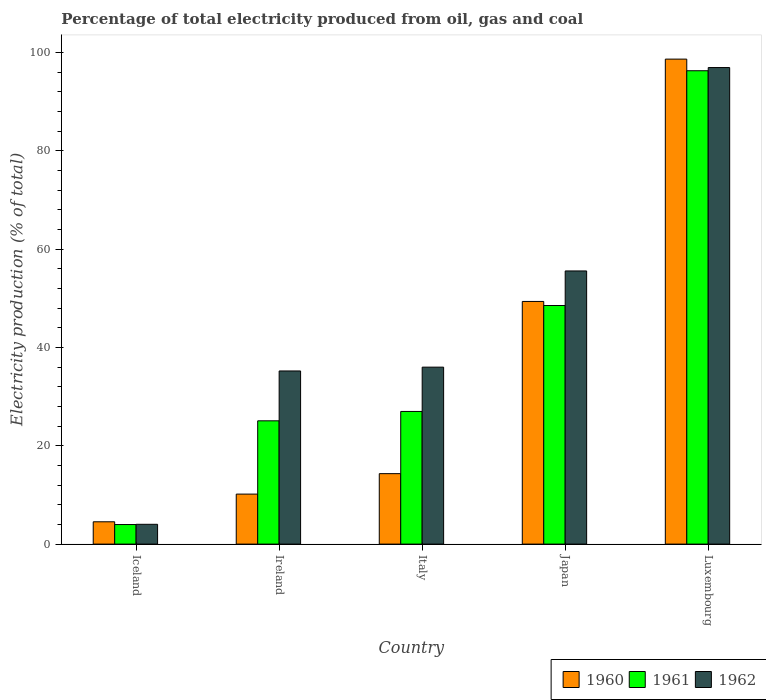How many bars are there on the 3rd tick from the left?
Your answer should be very brief. 3. What is the label of the 3rd group of bars from the left?
Offer a very short reply. Italy. What is the electricity production in in 1961 in Italy?
Give a very brief answer. 26.98. Across all countries, what is the maximum electricity production in in 1960?
Provide a succinct answer. 98.63. Across all countries, what is the minimum electricity production in in 1961?
Ensure brevity in your answer.  3.98. In which country was the electricity production in in 1962 maximum?
Give a very brief answer. Luxembourg. What is the total electricity production in in 1961 in the graph?
Keep it short and to the point. 200.82. What is the difference between the electricity production in in 1960 in Ireland and that in Japan?
Ensure brevity in your answer.  -39.18. What is the difference between the electricity production in in 1960 in Luxembourg and the electricity production in in 1961 in Iceland?
Give a very brief answer. 94.65. What is the average electricity production in in 1962 per country?
Your answer should be very brief. 45.54. What is the difference between the electricity production in of/in 1962 and electricity production in of/in 1961 in Japan?
Make the answer very short. 7.03. In how many countries, is the electricity production in in 1962 greater than 40 %?
Your answer should be compact. 2. What is the ratio of the electricity production in in 1962 in Ireland to that in Japan?
Your response must be concise. 0.63. What is the difference between the highest and the second highest electricity production in in 1960?
Provide a succinct answer. -49.28. What is the difference between the highest and the lowest electricity production in in 1962?
Give a very brief answer. 92.89. In how many countries, is the electricity production in in 1962 greater than the average electricity production in in 1962 taken over all countries?
Ensure brevity in your answer.  2. Is the sum of the electricity production in in 1961 in Japan and Luxembourg greater than the maximum electricity production in in 1960 across all countries?
Offer a very short reply. Yes. What does the 3rd bar from the right in Iceland represents?
Provide a short and direct response. 1960. Is it the case that in every country, the sum of the electricity production in in 1962 and electricity production in in 1960 is greater than the electricity production in in 1961?
Ensure brevity in your answer.  Yes. Are all the bars in the graph horizontal?
Provide a short and direct response. No. Are the values on the major ticks of Y-axis written in scientific E-notation?
Offer a very short reply. No. How are the legend labels stacked?
Ensure brevity in your answer.  Horizontal. What is the title of the graph?
Give a very brief answer. Percentage of total electricity produced from oil, gas and coal. What is the label or title of the X-axis?
Make the answer very short. Country. What is the label or title of the Y-axis?
Keep it short and to the point. Electricity production (% of total). What is the Electricity production (% of total) of 1960 in Iceland?
Make the answer very short. 4.54. What is the Electricity production (% of total) of 1961 in Iceland?
Give a very brief answer. 3.98. What is the Electricity production (% of total) of 1962 in Iceland?
Your response must be concise. 4.03. What is the Electricity production (% of total) of 1960 in Ireland?
Your answer should be very brief. 10.17. What is the Electricity production (% of total) of 1961 in Ireland?
Your answer should be very brief. 25.07. What is the Electricity production (% of total) of 1962 in Ireland?
Keep it short and to the point. 35.21. What is the Electricity production (% of total) in 1960 in Italy?
Provide a succinct answer. 14.33. What is the Electricity production (% of total) of 1961 in Italy?
Provide a short and direct response. 26.98. What is the Electricity production (% of total) in 1962 in Italy?
Provide a succinct answer. 35.99. What is the Electricity production (% of total) of 1960 in Japan?
Offer a terse response. 49.35. What is the Electricity production (% of total) in 1961 in Japan?
Your response must be concise. 48.52. What is the Electricity production (% of total) of 1962 in Japan?
Provide a succinct answer. 55.56. What is the Electricity production (% of total) in 1960 in Luxembourg?
Your answer should be very brief. 98.63. What is the Electricity production (% of total) of 1961 in Luxembourg?
Offer a very short reply. 96.27. What is the Electricity production (% of total) of 1962 in Luxembourg?
Offer a very short reply. 96.92. Across all countries, what is the maximum Electricity production (% of total) in 1960?
Your response must be concise. 98.63. Across all countries, what is the maximum Electricity production (% of total) in 1961?
Your response must be concise. 96.27. Across all countries, what is the maximum Electricity production (% of total) of 1962?
Your answer should be compact. 96.92. Across all countries, what is the minimum Electricity production (% of total) in 1960?
Offer a terse response. 4.54. Across all countries, what is the minimum Electricity production (% of total) in 1961?
Make the answer very short. 3.98. Across all countries, what is the minimum Electricity production (% of total) of 1962?
Your response must be concise. 4.03. What is the total Electricity production (% of total) in 1960 in the graph?
Make the answer very short. 177.02. What is the total Electricity production (% of total) in 1961 in the graph?
Offer a very short reply. 200.82. What is the total Electricity production (% of total) in 1962 in the graph?
Offer a very short reply. 227.7. What is the difference between the Electricity production (% of total) of 1960 in Iceland and that in Ireland?
Provide a short and direct response. -5.63. What is the difference between the Electricity production (% of total) of 1961 in Iceland and that in Ireland?
Offer a terse response. -21.09. What is the difference between the Electricity production (% of total) in 1962 in Iceland and that in Ireland?
Your response must be concise. -31.19. What is the difference between the Electricity production (% of total) of 1960 in Iceland and that in Italy?
Your response must be concise. -9.79. What is the difference between the Electricity production (% of total) in 1961 in Iceland and that in Italy?
Give a very brief answer. -23. What is the difference between the Electricity production (% of total) of 1962 in Iceland and that in Italy?
Give a very brief answer. -31.96. What is the difference between the Electricity production (% of total) of 1960 in Iceland and that in Japan?
Offer a very short reply. -44.81. What is the difference between the Electricity production (% of total) of 1961 in Iceland and that in Japan?
Make the answer very short. -44.54. What is the difference between the Electricity production (% of total) of 1962 in Iceland and that in Japan?
Your answer should be compact. -51.53. What is the difference between the Electricity production (% of total) of 1960 in Iceland and that in Luxembourg?
Provide a short and direct response. -94.1. What is the difference between the Electricity production (% of total) in 1961 in Iceland and that in Luxembourg?
Ensure brevity in your answer.  -92.29. What is the difference between the Electricity production (% of total) of 1962 in Iceland and that in Luxembourg?
Your response must be concise. -92.89. What is the difference between the Electricity production (% of total) of 1960 in Ireland and that in Italy?
Your answer should be compact. -4.16. What is the difference between the Electricity production (% of total) of 1961 in Ireland and that in Italy?
Provide a short and direct response. -1.91. What is the difference between the Electricity production (% of total) of 1962 in Ireland and that in Italy?
Provide a succinct answer. -0.78. What is the difference between the Electricity production (% of total) in 1960 in Ireland and that in Japan?
Offer a terse response. -39.18. What is the difference between the Electricity production (% of total) of 1961 in Ireland and that in Japan?
Provide a succinct answer. -23.45. What is the difference between the Electricity production (% of total) of 1962 in Ireland and that in Japan?
Keep it short and to the point. -20.34. What is the difference between the Electricity production (% of total) of 1960 in Ireland and that in Luxembourg?
Make the answer very short. -88.47. What is the difference between the Electricity production (% of total) of 1961 in Ireland and that in Luxembourg?
Make the answer very short. -71.2. What is the difference between the Electricity production (% of total) of 1962 in Ireland and that in Luxembourg?
Your response must be concise. -61.71. What is the difference between the Electricity production (% of total) in 1960 in Italy and that in Japan?
Give a very brief answer. -35.02. What is the difference between the Electricity production (% of total) in 1961 in Italy and that in Japan?
Your response must be concise. -21.55. What is the difference between the Electricity production (% of total) of 1962 in Italy and that in Japan?
Provide a succinct answer. -19.57. What is the difference between the Electricity production (% of total) of 1960 in Italy and that in Luxembourg?
Your response must be concise. -84.31. What is the difference between the Electricity production (% of total) of 1961 in Italy and that in Luxembourg?
Keep it short and to the point. -69.29. What is the difference between the Electricity production (% of total) of 1962 in Italy and that in Luxembourg?
Make the answer very short. -60.93. What is the difference between the Electricity production (% of total) of 1960 in Japan and that in Luxembourg?
Provide a succinct answer. -49.28. What is the difference between the Electricity production (% of total) in 1961 in Japan and that in Luxembourg?
Your response must be concise. -47.75. What is the difference between the Electricity production (% of total) in 1962 in Japan and that in Luxembourg?
Keep it short and to the point. -41.36. What is the difference between the Electricity production (% of total) of 1960 in Iceland and the Electricity production (% of total) of 1961 in Ireland?
Give a very brief answer. -20.53. What is the difference between the Electricity production (% of total) in 1960 in Iceland and the Electricity production (% of total) in 1962 in Ireland?
Provide a succinct answer. -30.67. What is the difference between the Electricity production (% of total) in 1961 in Iceland and the Electricity production (% of total) in 1962 in Ireland?
Ensure brevity in your answer.  -31.23. What is the difference between the Electricity production (% of total) in 1960 in Iceland and the Electricity production (% of total) in 1961 in Italy?
Offer a terse response. -22.44. What is the difference between the Electricity production (% of total) in 1960 in Iceland and the Electricity production (% of total) in 1962 in Italy?
Offer a terse response. -31.45. What is the difference between the Electricity production (% of total) of 1961 in Iceland and the Electricity production (% of total) of 1962 in Italy?
Ensure brevity in your answer.  -32.01. What is the difference between the Electricity production (% of total) in 1960 in Iceland and the Electricity production (% of total) in 1961 in Japan?
Make the answer very short. -43.99. What is the difference between the Electricity production (% of total) in 1960 in Iceland and the Electricity production (% of total) in 1962 in Japan?
Keep it short and to the point. -51.02. What is the difference between the Electricity production (% of total) in 1961 in Iceland and the Electricity production (% of total) in 1962 in Japan?
Give a very brief answer. -51.58. What is the difference between the Electricity production (% of total) in 1960 in Iceland and the Electricity production (% of total) in 1961 in Luxembourg?
Make the answer very short. -91.73. What is the difference between the Electricity production (% of total) in 1960 in Iceland and the Electricity production (% of total) in 1962 in Luxembourg?
Offer a terse response. -92.38. What is the difference between the Electricity production (% of total) in 1961 in Iceland and the Electricity production (% of total) in 1962 in Luxembourg?
Offer a terse response. -92.94. What is the difference between the Electricity production (% of total) in 1960 in Ireland and the Electricity production (% of total) in 1961 in Italy?
Your response must be concise. -16.81. What is the difference between the Electricity production (% of total) of 1960 in Ireland and the Electricity production (% of total) of 1962 in Italy?
Provide a succinct answer. -25.82. What is the difference between the Electricity production (% of total) of 1961 in Ireland and the Electricity production (% of total) of 1962 in Italy?
Make the answer very short. -10.92. What is the difference between the Electricity production (% of total) of 1960 in Ireland and the Electricity production (% of total) of 1961 in Japan?
Make the answer very short. -38.36. What is the difference between the Electricity production (% of total) in 1960 in Ireland and the Electricity production (% of total) in 1962 in Japan?
Make the answer very short. -45.39. What is the difference between the Electricity production (% of total) in 1961 in Ireland and the Electricity production (% of total) in 1962 in Japan?
Give a very brief answer. -30.48. What is the difference between the Electricity production (% of total) of 1960 in Ireland and the Electricity production (% of total) of 1961 in Luxembourg?
Provide a short and direct response. -86.1. What is the difference between the Electricity production (% of total) in 1960 in Ireland and the Electricity production (% of total) in 1962 in Luxembourg?
Make the answer very short. -86.75. What is the difference between the Electricity production (% of total) in 1961 in Ireland and the Electricity production (% of total) in 1962 in Luxembourg?
Ensure brevity in your answer.  -71.85. What is the difference between the Electricity production (% of total) of 1960 in Italy and the Electricity production (% of total) of 1961 in Japan?
Give a very brief answer. -34.2. What is the difference between the Electricity production (% of total) of 1960 in Italy and the Electricity production (% of total) of 1962 in Japan?
Your response must be concise. -41.23. What is the difference between the Electricity production (% of total) in 1961 in Italy and the Electricity production (% of total) in 1962 in Japan?
Provide a succinct answer. -28.58. What is the difference between the Electricity production (% of total) in 1960 in Italy and the Electricity production (% of total) in 1961 in Luxembourg?
Your response must be concise. -81.94. What is the difference between the Electricity production (% of total) in 1960 in Italy and the Electricity production (% of total) in 1962 in Luxembourg?
Make the answer very short. -82.59. What is the difference between the Electricity production (% of total) in 1961 in Italy and the Electricity production (% of total) in 1962 in Luxembourg?
Offer a terse response. -69.94. What is the difference between the Electricity production (% of total) in 1960 in Japan and the Electricity production (% of total) in 1961 in Luxembourg?
Provide a succinct answer. -46.92. What is the difference between the Electricity production (% of total) in 1960 in Japan and the Electricity production (% of total) in 1962 in Luxembourg?
Your response must be concise. -47.57. What is the difference between the Electricity production (% of total) in 1961 in Japan and the Electricity production (% of total) in 1962 in Luxembourg?
Give a very brief answer. -48.39. What is the average Electricity production (% of total) in 1960 per country?
Make the answer very short. 35.4. What is the average Electricity production (% of total) in 1961 per country?
Your answer should be very brief. 40.16. What is the average Electricity production (% of total) in 1962 per country?
Offer a terse response. 45.54. What is the difference between the Electricity production (% of total) in 1960 and Electricity production (% of total) in 1961 in Iceland?
Your response must be concise. 0.56. What is the difference between the Electricity production (% of total) of 1960 and Electricity production (% of total) of 1962 in Iceland?
Offer a very short reply. 0.51. What is the difference between the Electricity production (% of total) in 1961 and Electricity production (% of total) in 1962 in Iceland?
Your answer should be very brief. -0.05. What is the difference between the Electricity production (% of total) of 1960 and Electricity production (% of total) of 1961 in Ireland?
Your answer should be very brief. -14.9. What is the difference between the Electricity production (% of total) of 1960 and Electricity production (% of total) of 1962 in Ireland?
Provide a succinct answer. -25.04. What is the difference between the Electricity production (% of total) in 1961 and Electricity production (% of total) in 1962 in Ireland?
Give a very brief answer. -10.14. What is the difference between the Electricity production (% of total) in 1960 and Electricity production (% of total) in 1961 in Italy?
Your response must be concise. -12.65. What is the difference between the Electricity production (% of total) of 1960 and Electricity production (% of total) of 1962 in Italy?
Offer a very short reply. -21.66. What is the difference between the Electricity production (% of total) of 1961 and Electricity production (% of total) of 1962 in Italy?
Offer a terse response. -9.01. What is the difference between the Electricity production (% of total) of 1960 and Electricity production (% of total) of 1961 in Japan?
Your answer should be compact. 0.83. What is the difference between the Electricity production (% of total) of 1960 and Electricity production (% of total) of 1962 in Japan?
Give a very brief answer. -6.2. What is the difference between the Electricity production (% of total) in 1961 and Electricity production (% of total) in 1962 in Japan?
Offer a terse response. -7.03. What is the difference between the Electricity production (% of total) in 1960 and Electricity production (% of total) in 1961 in Luxembourg?
Make the answer very short. 2.36. What is the difference between the Electricity production (% of total) of 1960 and Electricity production (% of total) of 1962 in Luxembourg?
Your response must be concise. 1.72. What is the difference between the Electricity production (% of total) in 1961 and Electricity production (% of total) in 1962 in Luxembourg?
Offer a very short reply. -0.65. What is the ratio of the Electricity production (% of total) of 1960 in Iceland to that in Ireland?
Give a very brief answer. 0.45. What is the ratio of the Electricity production (% of total) in 1961 in Iceland to that in Ireland?
Offer a very short reply. 0.16. What is the ratio of the Electricity production (% of total) of 1962 in Iceland to that in Ireland?
Your response must be concise. 0.11. What is the ratio of the Electricity production (% of total) of 1960 in Iceland to that in Italy?
Offer a terse response. 0.32. What is the ratio of the Electricity production (% of total) in 1961 in Iceland to that in Italy?
Provide a short and direct response. 0.15. What is the ratio of the Electricity production (% of total) of 1962 in Iceland to that in Italy?
Give a very brief answer. 0.11. What is the ratio of the Electricity production (% of total) of 1960 in Iceland to that in Japan?
Make the answer very short. 0.09. What is the ratio of the Electricity production (% of total) of 1961 in Iceland to that in Japan?
Offer a terse response. 0.08. What is the ratio of the Electricity production (% of total) in 1962 in Iceland to that in Japan?
Provide a succinct answer. 0.07. What is the ratio of the Electricity production (% of total) of 1960 in Iceland to that in Luxembourg?
Offer a terse response. 0.05. What is the ratio of the Electricity production (% of total) in 1961 in Iceland to that in Luxembourg?
Offer a terse response. 0.04. What is the ratio of the Electricity production (% of total) of 1962 in Iceland to that in Luxembourg?
Your answer should be compact. 0.04. What is the ratio of the Electricity production (% of total) in 1960 in Ireland to that in Italy?
Your answer should be very brief. 0.71. What is the ratio of the Electricity production (% of total) in 1961 in Ireland to that in Italy?
Keep it short and to the point. 0.93. What is the ratio of the Electricity production (% of total) of 1962 in Ireland to that in Italy?
Make the answer very short. 0.98. What is the ratio of the Electricity production (% of total) of 1960 in Ireland to that in Japan?
Provide a short and direct response. 0.21. What is the ratio of the Electricity production (% of total) of 1961 in Ireland to that in Japan?
Your answer should be compact. 0.52. What is the ratio of the Electricity production (% of total) in 1962 in Ireland to that in Japan?
Offer a very short reply. 0.63. What is the ratio of the Electricity production (% of total) in 1960 in Ireland to that in Luxembourg?
Your answer should be very brief. 0.1. What is the ratio of the Electricity production (% of total) in 1961 in Ireland to that in Luxembourg?
Give a very brief answer. 0.26. What is the ratio of the Electricity production (% of total) in 1962 in Ireland to that in Luxembourg?
Your answer should be very brief. 0.36. What is the ratio of the Electricity production (% of total) of 1960 in Italy to that in Japan?
Keep it short and to the point. 0.29. What is the ratio of the Electricity production (% of total) in 1961 in Italy to that in Japan?
Provide a short and direct response. 0.56. What is the ratio of the Electricity production (% of total) of 1962 in Italy to that in Japan?
Give a very brief answer. 0.65. What is the ratio of the Electricity production (% of total) in 1960 in Italy to that in Luxembourg?
Your response must be concise. 0.15. What is the ratio of the Electricity production (% of total) in 1961 in Italy to that in Luxembourg?
Keep it short and to the point. 0.28. What is the ratio of the Electricity production (% of total) of 1962 in Italy to that in Luxembourg?
Provide a succinct answer. 0.37. What is the ratio of the Electricity production (% of total) in 1960 in Japan to that in Luxembourg?
Provide a succinct answer. 0.5. What is the ratio of the Electricity production (% of total) in 1961 in Japan to that in Luxembourg?
Give a very brief answer. 0.5. What is the ratio of the Electricity production (% of total) of 1962 in Japan to that in Luxembourg?
Give a very brief answer. 0.57. What is the difference between the highest and the second highest Electricity production (% of total) of 1960?
Ensure brevity in your answer.  49.28. What is the difference between the highest and the second highest Electricity production (% of total) in 1961?
Offer a terse response. 47.75. What is the difference between the highest and the second highest Electricity production (% of total) in 1962?
Your answer should be very brief. 41.36. What is the difference between the highest and the lowest Electricity production (% of total) in 1960?
Your response must be concise. 94.1. What is the difference between the highest and the lowest Electricity production (% of total) of 1961?
Give a very brief answer. 92.29. What is the difference between the highest and the lowest Electricity production (% of total) of 1962?
Ensure brevity in your answer.  92.89. 